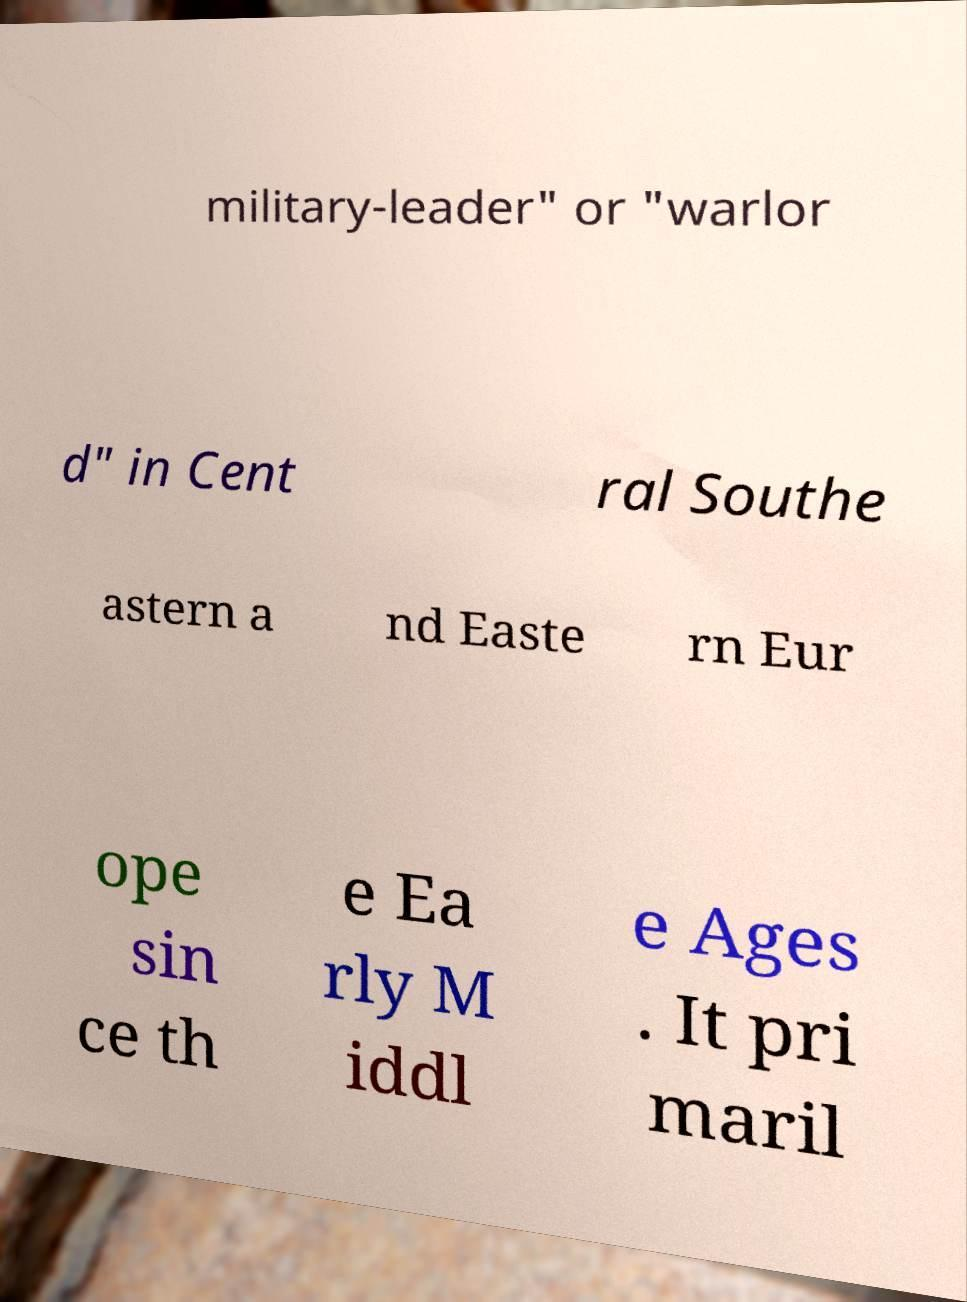What messages or text are displayed in this image? I need them in a readable, typed format. military-leader" or "warlor d" in Cent ral Southe astern a nd Easte rn Eur ope sin ce th e Ea rly M iddl e Ages . It pri maril 